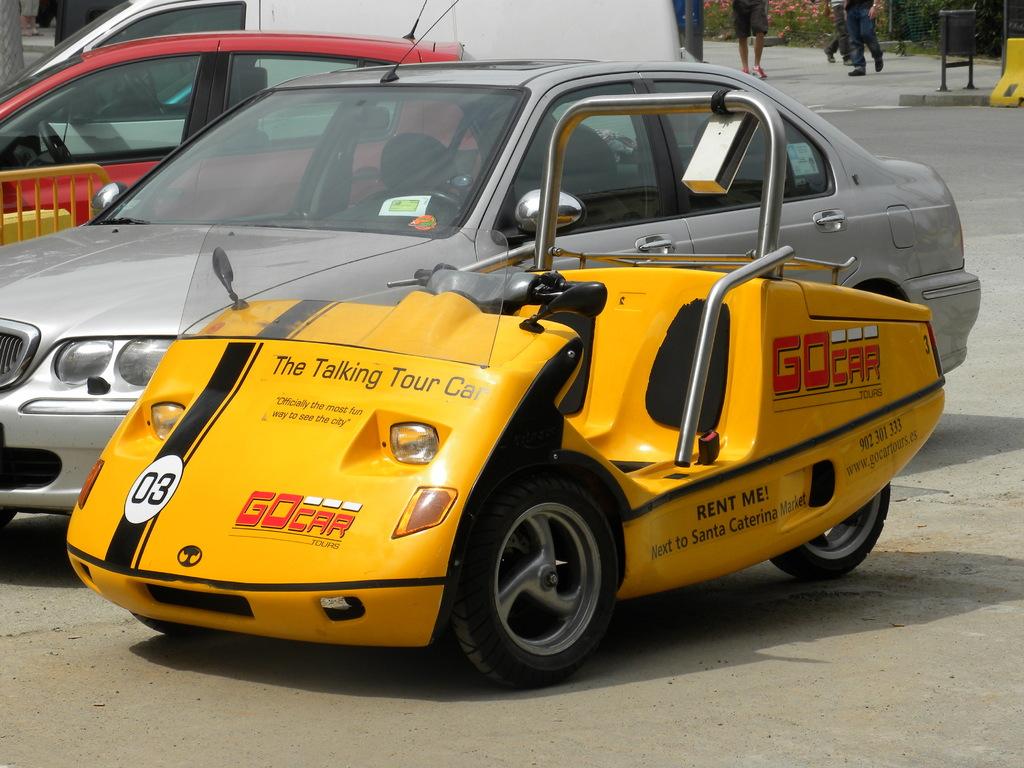What is the number on the front of this go car?
Make the answer very short. 03. What kind of a tour car is this?
Ensure brevity in your answer.  Talking. 